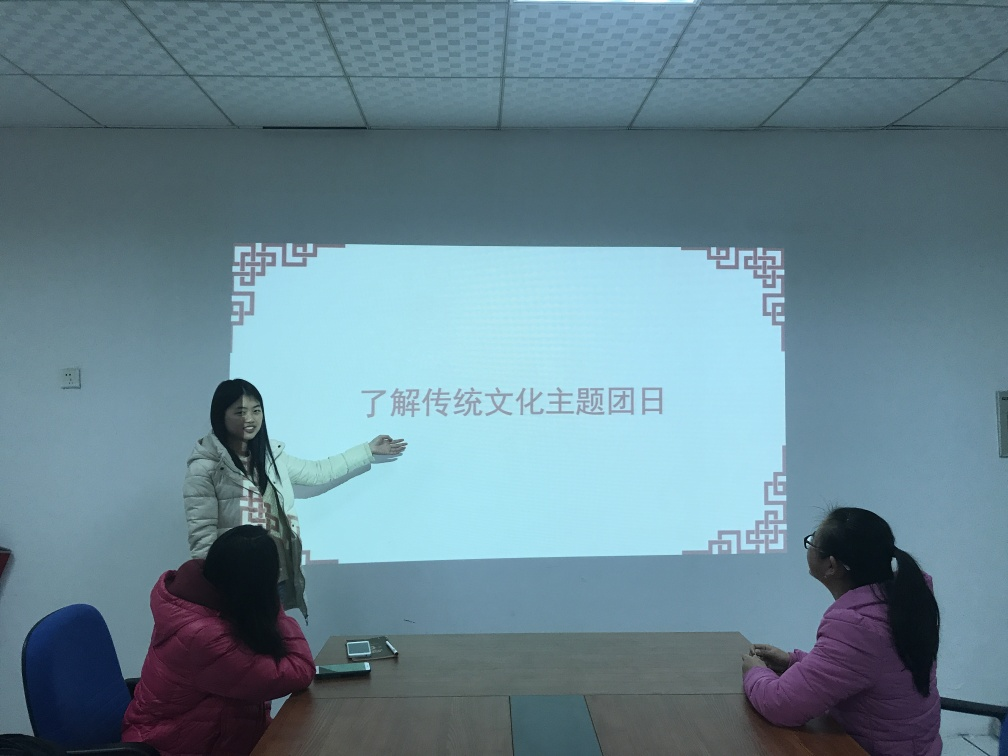Are the texture and details apparent in the image?
A. Yes
B. No
C. Inconspicuous
D. Blurry
Answer with the option's letter from the given choices directly.
 A. 